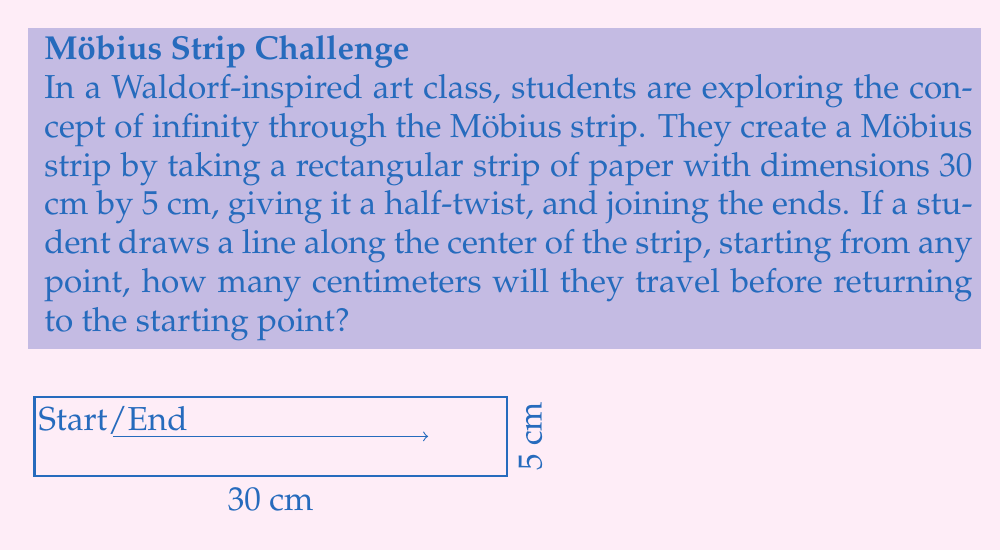Help me with this question. To solve this problem, let's break it down into steps:

1) First, we need to understand the properties of a Möbius strip:
   - It has only one side and one edge.
   - A line drawn along the center will traverse both "sides" before returning to the starting point.

2) The key insight is that the line will need to go around the strip twice before returning to the starting point. This is because:
   - On the first trip around, you end up on the "other side" of where you started.
   - It takes a second trip to get back to the original side and position.

3) Now, let's calculate the length of the center line:
   - The strip is 30 cm long.
   - The center line goes around twice.
   - So the total distance is: $2 * 30 = 60$ cm

4) We can verify this mathematically:
   Let $L$ be the length of the strip and $d$ be the distance traveled.
   $$d = 2L = 2 * 30 = 60\text{ cm}$$

5) This result aligns with the topological properties of the Möbius strip, demonstrating the concept of a single-sided surface and its relation to infinity, which is a key theme in both topology and Waldorf-inspired artistic expression.
Answer: 60 cm 